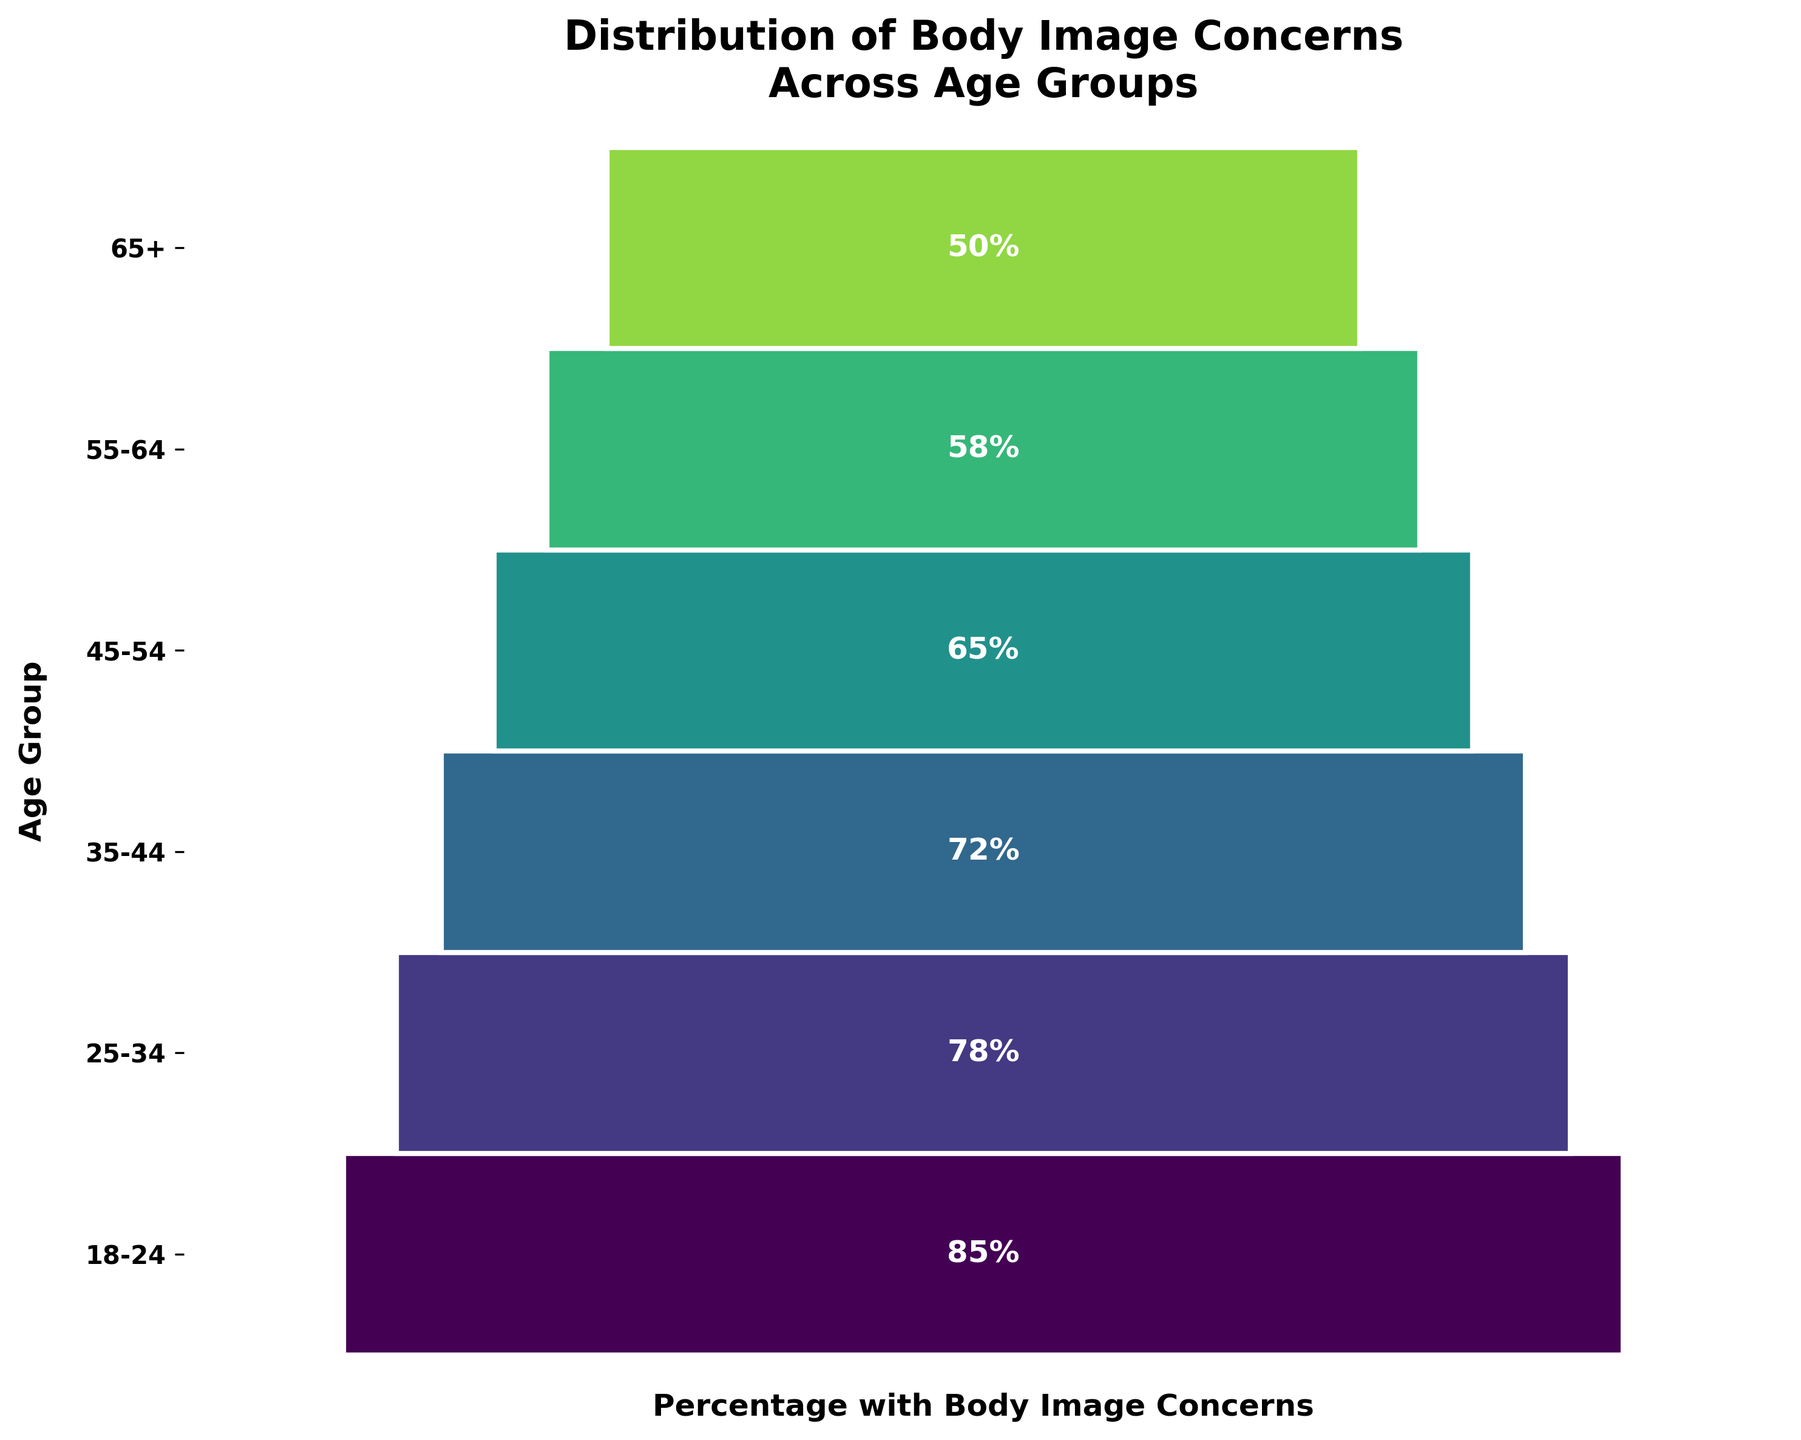Which age group has the highest percentage of body image concerns? By examining the funnel chart, the top segment represents the age group with the highest percentage. The topmost segment corresponds to the 18-24 age group with 85%.
Answer: 18-24 Which age group has the lowest percentage of body image concerns? Looking at the bottom of the funnel chart, the lowest segment represents the age group with the least percentage of concerns. The bottom segment corresponds to the 65+ age group with 50%.
Answer: 65+ What is the percentage difference in body image concerns between the 18-24 age group and the 65+ age group? Subtract the percentage of the 65+ age group from the percentage of the 18-24 age group: 85% - 50% = 35%.
Answer: 35% Which age group experiences a decrease of 14% in body image concerns from the previous age group? The data shows a drop of 14% from 85% at 18-24 to 71% at 35-44: 85% - 71% = 14%. Look for a transition of 14%. The transition between 35-44 and 45-54 is 14% as 72%-58% = 14%.
Answer: 35-44 and 45-54 Are body image concerns higher in the 25-34 age group or the 55-64 age group? Compare the percentages directly. The 25-34 age group has 78%, while the 55-64 age group has 58%. 78% is greater than 58%.
Answer: 25-34 What is the average percentage of body image concerns among all age groups? Sum up the percentages for all age groups and divide by the number of age groups: (85+78+72+65+58+50)/6 = 68%.
Answer: 68% Which age groups have a percentage of body image concerns higher than the overall average? Calculate the average first (68%) and compare each group: 18-24 (85%), 25-34 (78%), and 35-44 (72%) are all higher than 68%.
Answer: 18-24, 25-34, 35-44 What is the mean difference in percentage of body image concerns between consecutive age groups? Calculate each difference and find the mean: (85-78) + (78-72) + (72-65) + (65-58) + (58-50) = 7+6+7+7+8 = 35; 35/5 = 7%.
Answer: 7% Does the percentage of body image concerns continuously decrease with increasing age? By examining the data from the funnel chart, every subsequent age group shows a lower percentage than the previous one, indicating a continuous decrease.
Answer: Yes Which age group has a percentage of body image concerns closest to 60%? Compare each percentage to 60% and find the nearest: 58% for the 55-64 age group is closest to 60%.
Answer: 55-64 